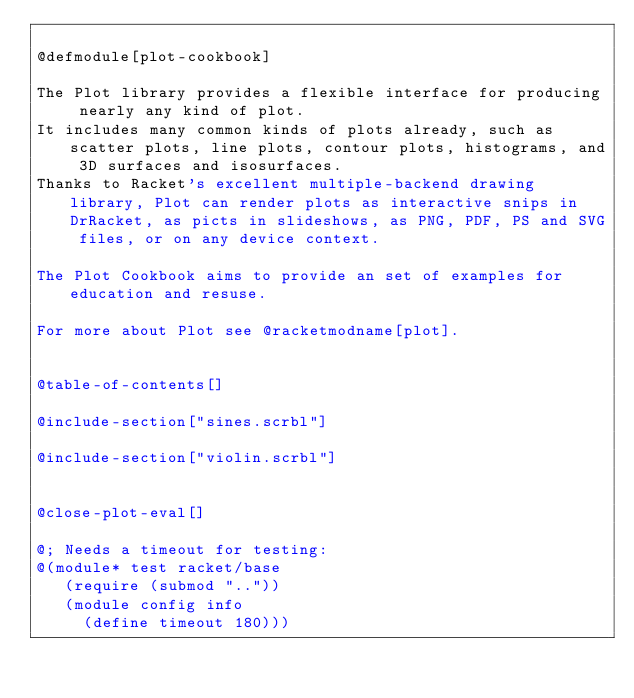<code> <loc_0><loc_0><loc_500><loc_500><_Racket_>
@defmodule[plot-cookbook]

The Plot library provides a flexible interface for producing nearly any kind of plot.
It includes many common kinds of plots already, such as scatter plots, line plots, contour plots, histograms, and 3D surfaces and isosurfaces.
Thanks to Racket's excellent multiple-backend drawing library, Plot can render plots as interactive snips in DrRacket, as picts in slideshows, as PNG, PDF, PS and SVG files, or on any device context.

The Plot Cookbook aims to provide an set of examples for education and resuse.

For more about Plot see @racketmodname[plot].


@table-of-contents[]

@include-section["sines.scrbl"]

@include-section["violin.scrbl"]


@close-plot-eval[]

@; Needs a timeout for testing:
@(module* test racket/base
   (require (submod ".."))
   (module config info
     (define timeout 180)))</code> 